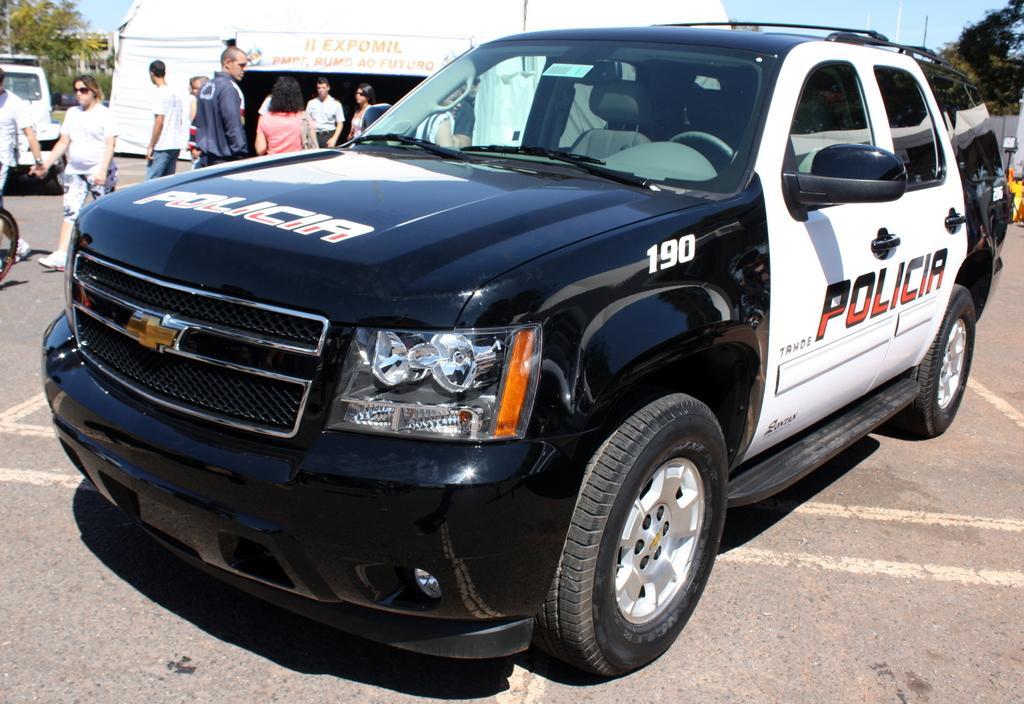In one or two sentences, can you explain what this image depicts? This picture shows a police car and we see few of them walking and few are standing and we see a tent and few trees and a blue sky and we see a vehicle parked on the side. 